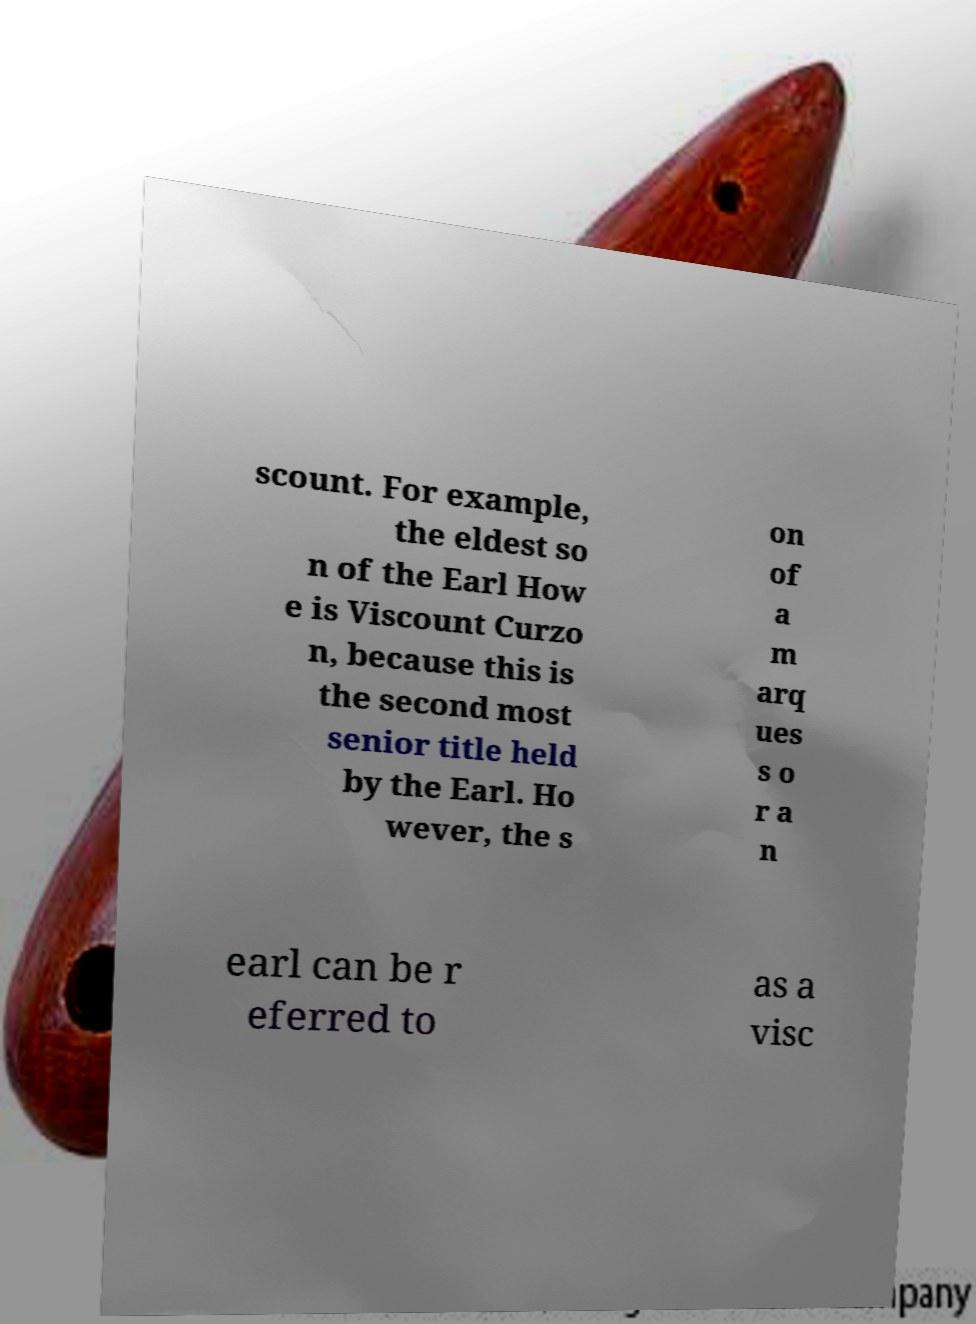Can you read and provide the text displayed in the image?This photo seems to have some interesting text. Can you extract and type it out for me? scount. For example, the eldest so n of the Earl How e is Viscount Curzo n, because this is the second most senior title held by the Earl. Ho wever, the s on of a m arq ues s o r a n earl can be r eferred to as a visc 